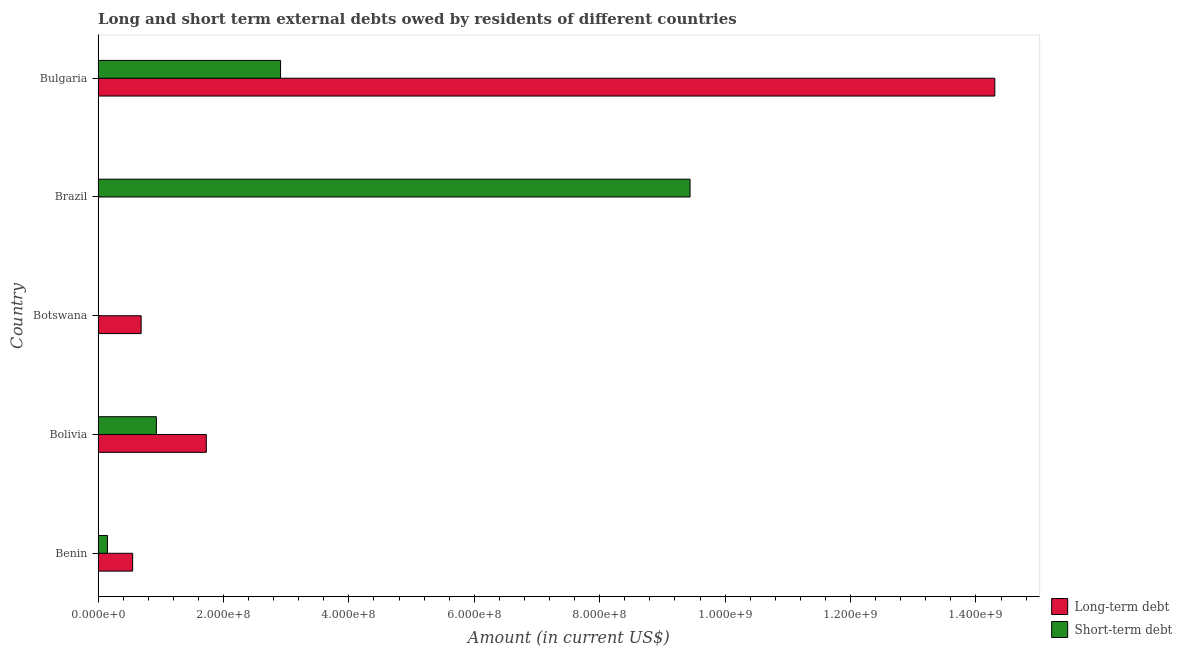How many different coloured bars are there?
Ensure brevity in your answer.  2. How many bars are there on the 4th tick from the top?
Keep it short and to the point. 2. What is the label of the 3rd group of bars from the top?
Offer a very short reply. Botswana. In how many cases, is the number of bars for a given country not equal to the number of legend labels?
Ensure brevity in your answer.  1. What is the short-term debts owed by residents in Benin?
Offer a very short reply. 1.50e+07. Across all countries, what is the maximum long-term debts owed by residents?
Your answer should be very brief. 1.43e+09. Across all countries, what is the minimum short-term debts owed by residents?
Offer a very short reply. 2.00e+05. In which country was the long-term debts owed by residents maximum?
Provide a short and direct response. Bulgaria. What is the total long-term debts owed by residents in the graph?
Ensure brevity in your answer.  1.73e+09. What is the difference between the long-term debts owed by residents in Bolivia and that in Bulgaria?
Provide a succinct answer. -1.26e+09. What is the difference between the long-term debts owed by residents in Botswana and the short-term debts owed by residents in Bulgaria?
Make the answer very short. -2.22e+08. What is the average short-term debts owed by residents per country?
Keep it short and to the point. 2.69e+08. What is the difference between the long-term debts owed by residents and short-term debts owed by residents in Benin?
Give a very brief answer. 4.01e+07. In how many countries, is the short-term debts owed by residents greater than 1400000000 US$?
Ensure brevity in your answer.  0. What is the ratio of the short-term debts owed by residents in Bolivia to that in Bulgaria?
Your response must be concise. 0.32. Is the short-term debts owed by residents in Benin less than that in Bolivia?
Your answer should be very brief. Yes. Is the difference between the short-term debts owed by residents in Benin and Bolivia greater than the difference between the long-term debts owed by residents in Benin and Bolivia?
Your response must be concise. Yes. What is the difference between the highest and the second highest long-term debts owed by residents?
Your answer should be compact. 1.26e+09. What is the difference between the highest and the lowest short-term debts owed by residents?
Provide a succinct answer. 9.44e+08. Are all the bars in the graph horizontal?
Ensure brevity in your answer.  Yes. Are the values on the major ticks of X-axis written in scientific E-notation?
Make the answer very short. Yes. Does the graph contain any zero values?
Give a very brief answer. Yes. Does the graph contain grids?
Offer a very short reply. No. How are the legend labels stacked?
Ensure brevity in your answer.  Vertical. What is the title of the graph?
Ensure brevity in your answer.  Long and short term external debts owed by residents of different countries. What is the label or title of the Y-axis?
Offer a very short reply. Country. What is the Amount (in current US$) of Long-term debt in Benin?
Give a very brief answer. 5.51e+07. What is the Amount (in current US$) of Short-term debt in Benin?
Keep it short and to the point. 1.50e+07. What is the Amount (in current US$) of Long-term debt in Bolivia?
Give a very brief answer. 1.73e+08. What is the Amount (in current US$) in Short-term debt in Bolivia?
Give a very brief answer. 9.30e+07. What is the Amount (in current US$) of Long-term debt in Botswana?
Your answer should be very brief. 6.87e+07. What is the Amount (in current US$) of Long-term debt in Brazil?
Keep it short and to the point. 0. What is the Amount (in current US$) in Short-term debt in Brazil?
Provide a short and direct response. 9.44e+08. What is the Amount (in current US$) in Long-term debt in Bulgaria?
Provide a succinct answer. 1.43e+09. What is the Amount (in current US$) of Short-term debt in Bulgaria?
Your response must be concise. 2.91e+08. Across all countries, what is the maximum Amount (in current US$) of Long-term debt?
Your response must be concise. 1.43e+09. Across all countries, what is the maximum Amount (in current US$) of Short-term debt?
Your answer should be very brief. 9.44e+08. What is the total Amount (in current US$) of Long-term debt in the graph?
Offer a terse response. 1.73e+09. What is the total Amount (in current US$) in Short-term debt in the graph?
Provide a succinct answer. 1.34e+09. What is the difference between the Amount (in current US$) of Long-term debt in Benin and that in Bolivia?
Offer a terse response. -1.17e+08. What is the difference between the Amount (in current US$) in Short-term debt in Benin and that in Bolivia?
Keep it short and to the point. -7.80e+07. What is the difference between the Amount (in current US$) in Long-term debt in Benin and that in Botswana?
Offer a terse response. -1.35e+07. What is the difference between the Amount (in current US$) of Short-term debt in Benin and that in Botswana?
Offer a terse response. 1.48e+07. What is the difference between the Amount (in current US$) of Short-term debt in Benin and that in Brazil?
Offer a terse response. -9.29e+08. What is the difference between the Amount (in current US$) in Long-term debt in Benin and that in Bulgaria?
Keep it short and to the point. -1.37e+09. What is the difference between the Amount (in current US$) of Short-term debt in Benin and that in Bulgaria?
Give a very brief answer. -2.76e+08. What is the difference between the Amount (in current US$) in Long-term debt in Bolivia and that in Botswana?
Your response must be concise. 1.04e+08. What is the difference between the Amount (in current US$) in Short-term debt in Bolivia and that in Botswana?
Make the answer very short. 9.28e+07. What is the difference between the Amount (in current US$) of Short-term debt in Bolivia and that in Brazil?
Provide a succinct answer. -8.51e+08. What is the difference between the Amount (in current US$) of Long-term debt in Bolivia and that in Bulgaria?
Your response must be concise. -1.26e+09. What is the difference between the Amount (in current US$) in Short-term debt in Bolivia and that in Bulgaria?
Make the answer very short. -1.98e+08. What is the difference between the Amount (in current US$) of Short-term debt in Botswana and that in Brazil?
Ensure brevity in your answer.  -9.44e+08. What is the difference between the Amount (in current US$) of Long-term debt in Botswana and that in Bulgaria?
Provide a short and direct response. -1.36e+09. What is the difference between the Amount (in current US$) of Short-term debt in Botswana and that in Bulgaria?
Offer a very short reply. -2.91e+08. What is the difference between the Amount (in current US$) in Short-term debt in Brazil and that in Bulgaria?
Give a very brief answer. 6.53e+08. What is the difference between the Amount (in current US$) of Long-term debt in Benin and the Amount (in current US$) of Short-term debt in Bolivia?
Your response must be concise. -3.79e+07. What is the difference between the Amount (in current US$) in Long-term debt in Benin and the Amount (in current US$) in Short-term debt in Botswana?
Make the answer very short. 5.49e+07. What is the difference between the Amount (in current US$) of Long-term debt in Benin and the Amount (in current US$) of Short-term debt in Brazil?
Keep it short and to the point. -8.89e+08. What is the difference between the Amount (in current US$) of Long-term debt in Benin and the Amount (in current US$) of Short-term debt in Bulgaria?
Your answer should be very brief. -2.36e+08. What is the difference between the Amount (in current US$) in Long-term debt in Bolivia and the Amount (in current US$) in Short-term debt in Botswana?
Give a very brief answer. 1.72e+08. What is the difference between the Amount (in current US$) of Long-term debt in Bolivia and the Amount (in current US$) of Short-term debt in Brazil?
Keep it short and to the point. -7.71e+08. What is the difference between the Amount (in current US$) in Long-term debt in Bolivia and the Amount (in current US$) in Short-term debt in Bulgaria?
Make the answer very short. -1.18e+08. What is the difference between the Amount (in current US$) in Long-term debt in Botswana and the Amount (in current US$) in Short-term debt in Brazil?
Provide a succinct answer. -8.75e+08. What is the difference between the Amount (in current US$) in Long-term debt in Botswana and the Amount (in current US$) in Short-term debt in Bulgaria?
Offer a terse response. -2.22e+08. What is the average Amount (in current US$) in Long-term debt per country?
Give a very brief answer. 3.45e+08. What is the average Amount (in current US$) in Short-term debt per country?
Keep it short and to the point. 2.69e+08. What is the difference between the Amount (in current US$) in Long-term debt and Amount (in current US$) in Short-term debt in Benin?
Your answer should be very brief. 4.01e+07. What is the difference between the Amount (in current US$) in Long-term debt and Amount (in current US$) in Short-term debt in Bolivia?
Your answer should be very brief. 7.96e+07. What is the difference between the Amount (in current US$) of Long-term debt and Amount (in current US$) of Short-term debt in Botswana?
Offer a terse response. 6.85e+07. What is the difference between the Amount (in current US$) of Long-term debt and Amount (in current US$) of Short-term debt in Bulgaria?
Your answer should be compact. 1.14e+09. What is the ratio of the Amount (in current US$) of Long-term debt in Benin to that in Bolivia?
Provide a succinct answer. 0.32. What is the ratio of the Amount (in current US$) of Short-term debt in Benin to that in Bolivia?
Keep it short and to the point. 0.16. What is the ratio of the Amount (in current US$) in Long-term debt in Benin to that in Botswana?
Offer a terse response. 0.8. What is the ratio of the Amount (in current US$) in Short-term debt in Benin to that in Brazil?
Provide a short and direct response. 0.02. What is the ratio of the Amount (in current US$) of Long-term debt in Benin to that in Bulgaria?
Provide a succinct answer. 0.04. What is the ratio of the Amount (in current US$) in Short-term debt in Benin to that in Bulgaria?
Keep it short and to the point. 0.05. What is the ratio of the Amount (in current US$) of Long-term debt in Bolivia to that in Botswana?
Make the answer very short. 2.51. What is the ratio of the Amount (in current US$) in Short-term debt in Bolivia to that in Botswana?
Offer a terse response. 465. What is the ratio of the Amount (in current US$) in Short-term debt in Bolivia to that in Brazil?
Make the answer very short. 0.1. What is the ratio of the Amount (in current US$) in Long-term debt in Bolivia to that in Bulgaria?
Offer a very short reply. 0.12. What is the ratio of the Amount (in current US$) of Short-term debt in Bolivia to that in Bulgaria?
Offer a very short reply. 0.32. What is the ratio of the Amount (in current US$) of Long-term debt in Botswana to that in Bulgaria?
Ensure brevity in your answer.  0.05. What is the ratio of the Amount (in current US$) of Short-term debt in Botswana to that in Bulgaria?
Offer a terse response. 0. What is the ratio of the Amount (in current US$) in Short-term debt in Brazil to that in Bulgaria?
Make the answer very short. 3.24. What is the difference between the highest and the second highest Amount (in current US$) of Long-term debt?
Ensure brevity in your answer.  1.26e+09. What is the difference between the highest and the second highest Amount (in current US$) in Short-term debt?
Your answer should be very brief. 6.53e+08. What is the difference between the highest and the lowest Amount (in current US$) in Long-term debt?
Your response must be concise. 1.43e+09. What is the difference between the highest and the lowest Amount (in current US$) of Short-term debt?
Your answer should be very brief. 9.44e+08. 